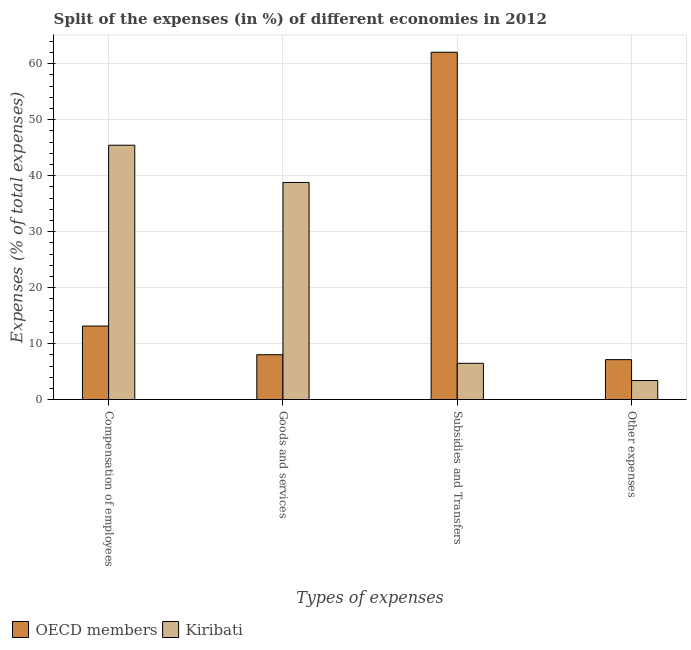How many groups of bars are there?
Make the answer very short. 4. Are the number of bars per tick equal to the number of legend labels?
Ensure brevity in your answer.  Yes. How many bars are there on the 3rd tick from the right?
Give a very brief answer. 2. What is the label of the 3rd group of bars from the left?
Give a very brief answer. Subsidies and Transfers. What is the percentage of amount spent on subsidies in Kiribati?
Provide a succinct answer. 6.48. Across all countries, what is the maximum percentage of amount spent on compensation of employees?
Your response must be concise. 45.44. Across all countries, what is the minimum percentage of amount spent on other expenses?
Ensure brevity in your answer.  3.41. In which country was the percentage of amount spent on goods and services minimum?
Keep it short and to the point. OECD members. What is the total percentage of amount spent on other expenses in the graph?
Ensure brevity in your answer.  10.55. What is the difference between the percentage of amount spent on other expenses in Kiribati and that in OECD members?
Ensure brevity in your answer.  -3.73. What is the difference between the percentage of amount spent on goods and services in Kiribati and the percentage of amount spent on other expenses in OECD members?
Provide a short and direct response. 31.65. What is the average percentage of amount spent on goods and services per country?
Offer a terse response. 23.41. What is the difference between the percentage of amount spent on compensation of employees and percentage of amount spent on subsidies in Kiribati?
Your answer should be compact. 38.96. What is the ratio of the percentage of amount spent on compensation of employees in Kiribati to that in OECD members?
Provide a short and direct response. 3.46. Is the difference between the percentage of amount spent on compensation of employees in Kiribati and OECD members greater than the difference between the percentage of amount spent on goods and services in Kiribati and OECD members?
Provide a short and direct response. Yes. What is the difference between the highest and the second highest percentage of amount spent on compensation of employees?
Your response must be concise. 32.3. What is the difference between the highest and the lowest percentage of amount spent on goods and services?
Keep it short and to the point. 30.77. In how many countries, is the percentage of amount spent on subsidies greater than the average percentage of amount spent on subsidies taken over all countries?
Offer a terse response. 1. Is the sum of the percentage of amount spent on other expenses in Kiribati and OECD members greater than the maximum percentage of amount spent on subsidies across all countries?
Provide a succinct answer. No. What does the 2nd bar from the left in Compensation of employees represents?
Keep it short and to the point. Kiribati. What does the 1st bar from the right in Compensation of employees represents?
Ensure brevity in your answer.  Kiribati. Is it the case that in every country, the sum of the percentage of amount spent on compensation of employees and percentage of amount spent on goods and services is greater than the percentage of amount spent on subsidies?
Your answer should be very brief. No. How many bars are there?
Provide a succinct answer. 8. How many countries are there in the graph?
Offer a terse response. 2. Are the values on the major ticks of Y-axis written in scientific E-notation?
Give a very brief answer. No. Does the graph contain any zero values?
Your response must be concise. No. Does the graph contain grids?
Your answer should be compact. Yes. How many legend labels are there?
Your response must be concise. 2. How are the legend labels stacked?
Your answer should be very brief. Horizontal. What is the title of the graph?
Offer a very short reply. Split of the expenses (in %) of different economies in 2012. What is the label or title of the X-axis?
Your answer should be very brief. Types of expenses. What is the label or title of the Y-axis?
Keep it short and to the point. Expenses (% of total expenses). What is the Expenses (% of total expenses) in OECD members in Compensation of employees?
Give a very brief answer. 13.14. What is the Expenses (% of total expenses) of Kiribati in Compensation of employees?
Your answer should be very brief. 45.44. What is the Expenses (% of total expenses) in OECD members in Goods and services?
Offer a very short reply. 8.02. What is the Expenses (% of total expenses) of Kiribati in Goods and services?
Ensure brevity in your answer.  38.79. What is the Expenses (% of total expenses) of OECD members in Subsidies and Transfers?
Give a very brief answer. 62.05. What is the Expenses (% of total expenses) in Kiribati in Subsidies and Transfers?
Provide a succinct answer. 6.48. What is the Expenses (% of total expenses) of OECD members in Other expenses?
Keep it short and to the point. 7.14. What is the Expenses (% of total expenses) of Kiribati in Other expenses?
Your answer should be compact. 3.41. Across all Types of expenses, what is the maximum Expenses (% of total expenses) in OECD members?
Your answer should be very brief. 62.05. Across all Types of expenses, what is the maximum Expenses (% of total expenses) in Kiribati?
Provide a succinct answer. 45.44. Across all Types of expenses, what is the minimum Expenses (% of total expenses) of OECD members?
Make the answer very short. 7.14. Across all Types of expenses, what is the minimum Expenses (% of total expenses) in Kiribati?
Make the answer very short. 3.41. What is the total Expenses (% of total expenses) in OECD members in the graph?
Your response must be concise. 90.35. What is the total Expenses (% of total expenses) in Kiribati in the graph?
Ensure brevity in your answer.  94.13. What is the difference between the Expenses (% of total expenses) of OECD members in Compensation of employees and that in Goods and services?
Provide a short and direct response. 5.12. What is the difference between the Expenses (% of total expenses) of Kiribati in Compensation of employees and that in Goods and services?
Give a very brief answer. 6.65. What is the difference between the Expenses (% of total expenses) in OECD members in Compensation of employees and that in Subsidies and Transfers?
Your answer should be very brief. -48.91. What is the difference between the Expenses (% of total expenses) of Kiribati in Compensation of employees and that in Subsidies and Transfers?
Give a very brief answer. 38.96. What is the difference between the Expenses (% of total expenses) of OECD members in Compensation of employees and that in Other expenses?
Offer a terse response. 6. What is the difference between the Expenses (% of total expenses) of Kiribati in Compensation of employees and that in Other expenses?
Keep it short and to the point. 42.03. What is the difference between the Expenses (% of total expenses) in OECD members in Goods and services and that in Subsidies and Transfers?
Provide a short and direct response. -54.03. What is the difference between the Expenses (% of total expenses) of Kiribati in Goods and services and that in Subsidies and Transfers?
Offer a very short reply. 32.31. What is the difference between the Expenses (% of total expenses) of OECD members in Goods and services and that in Other expenses?
Offer a terse response. 0.88. What is the difference between the Expenses (% of total expenses) of Kiribati in Goods and services and that in Other expenses?
Your answer should be very brief. 35.38. What is the difference between the Expenses (% of total expenses) of OECD members in Subsidies and Transfers and that in Other expenses?
Provide a short and direct response. 54.91. What is the difference between the Expenses (% of total expenses) in Kiribati in Subsidies and Transfers and that in Other expenses?
Provide a short and direct response. 3.07. What is the difference between the Expenses (% of total expenses) of OECD members in Compensation of employees and the Expenses (% of total expenses) of Kiribati in Goods and services?
Keep it short and to the point. -25.65. What is the difference between the Expenses (% of total expenses) in OECD members in Compensation of employees and the Expenses (% of total expenses) in Kiribati in Subsidies and Transfers?
Keep it short and to the point. 6.66. What is the difference between the Expenses (% of total expenses) of OECD members in Compensation of employees and the Expenses (% of total expenses) of Kiribati in Other expenses?
Ensure brevity in your answer.  9.73. What is the difference between the Expenses (% of total expenses) of OECD members in Goods and services and the Expenses (% of total expenses) of Kiribati in Subsidies and Transfers?
Your answer should be very brief. 1.54. What is the difference between the Expenses (% of total expenses) of OECD members in Goods and services and the Expenses (% of total expenses) of Kiribati in Other expenses?
Ensure brevity in your answer.  4.61. What is the difference between the Expenses (% of total expenses) in OECD members in Subsidies and Transfers and the Expenses (% of total expenses) in Kiribati in Other expenses?
Your answer should be compact. 58.64. What is the average Expenses (% of total expenses) in OECD members per Types of expenses?
Offer a terse response. 22.59. What is the average Expenses (% of total expenses) in Kiribati per Types of expenses?
Provide a short and direct response. 23.53. What is the difference between the Expenses (% of total expenses) in OECD members and Expenses (% of total expenses) in Kiribati in Compensation of employees?
Keep it short and to the point. -32.3. What is the difference between the Expenses (% of total expenses) in OECD members and Expenses (% of total expenses) in Kiribati in Goods and services?
Your answer should be very brief. -30.77. What is the difference between the Expenses (% of total expenses) in OECD members and Expenses (% of total expenses) in Kiribati in Subsidies and Transfers?
Your answer should be very brief. 55.57. What is the difference between the Expenses (% of total expenses) of OECD members and Expenses (% of total expenses) of Kiribati in Other expenses?
Keep it short and to the point. 3.73. What is the ratio of the Expenses (% of total expenses) in OECD members in Compensation of employees to that in Goods and services?
Offer a very short reply. 1.64. What is the ratio of the Expenses (% of total expenses) in Kiribati in Compensation of employees to that in Goods and services?
Your answer should be very brief. 1.17. What is the ratio of the Expenses (% of total expenses) in OECD members in Compensation of employees to that in Subsidies and Transfers?
Provide a short and direct response. 0.21. What is the ratio of the Expenses (% of total expenses) of Kiribati in Compensation of employees to that in Subsidies and Transfers?
Your answer should be very brief. 7.01. What is the ratio of the Expenses (% of total expenses) in OECD members in Compensation of employees to that in Other expenses?
Provide a short and direct response. 1.84. What is the ratio of the Expenses (% of total expenses) in Kiribati in Compensation of employees to that in Other expenses?
Offer a very short reply. 13.33. What is the ratio of the Expenses (% of total expenses) in OECD members in Goods and services to that in Subsidies and Transfers?
Keep it short and to the point. 0.13. What is the ratio of the Expenses (% of total expenses) in Kiribati in Goods and services to that in Subsidies and Transfers?
Ensure brevity in your answer.  5.98. What is the ratio of the Expenses (% of total expenses) of OECD members in Goods and services to that in Other expenses?
Make the answer very short. 1.12. What is the ratio of the Expenses (% of total expenses) of Kiribati in Goods and services to that in Other expenses?
Your answer should be very brief. 11.38. What is the ratio of the Expenses (% of total expenses) of OECD members in Subsidies and Transfers to that in Other expenses?
Your answer should be compact. 8.69. What is the ratio of the Expenses (% of total expenses) of Kiribati in Subsidies and Transfers to that in Other expenses?
Provide a short and direct response. 1.9. What is the difference between the highest and the second highest Expenses (% of total expenses) of OECD members?
Your answer should be compact. 48.91. What is the difference between the highest and the second highest Expenses (% of total expenses) in Kiribati?
Your answer should be compact. 6.65. What is the difference between the highest and the lowest Expenses (% of total expenses) of OECD members?
Provide a succinct answer. 54.91. What is the difference between the highest and the lowest Expenses (% of total expenses) in Kiribati?
Provide a succinct answer. 42.03. 